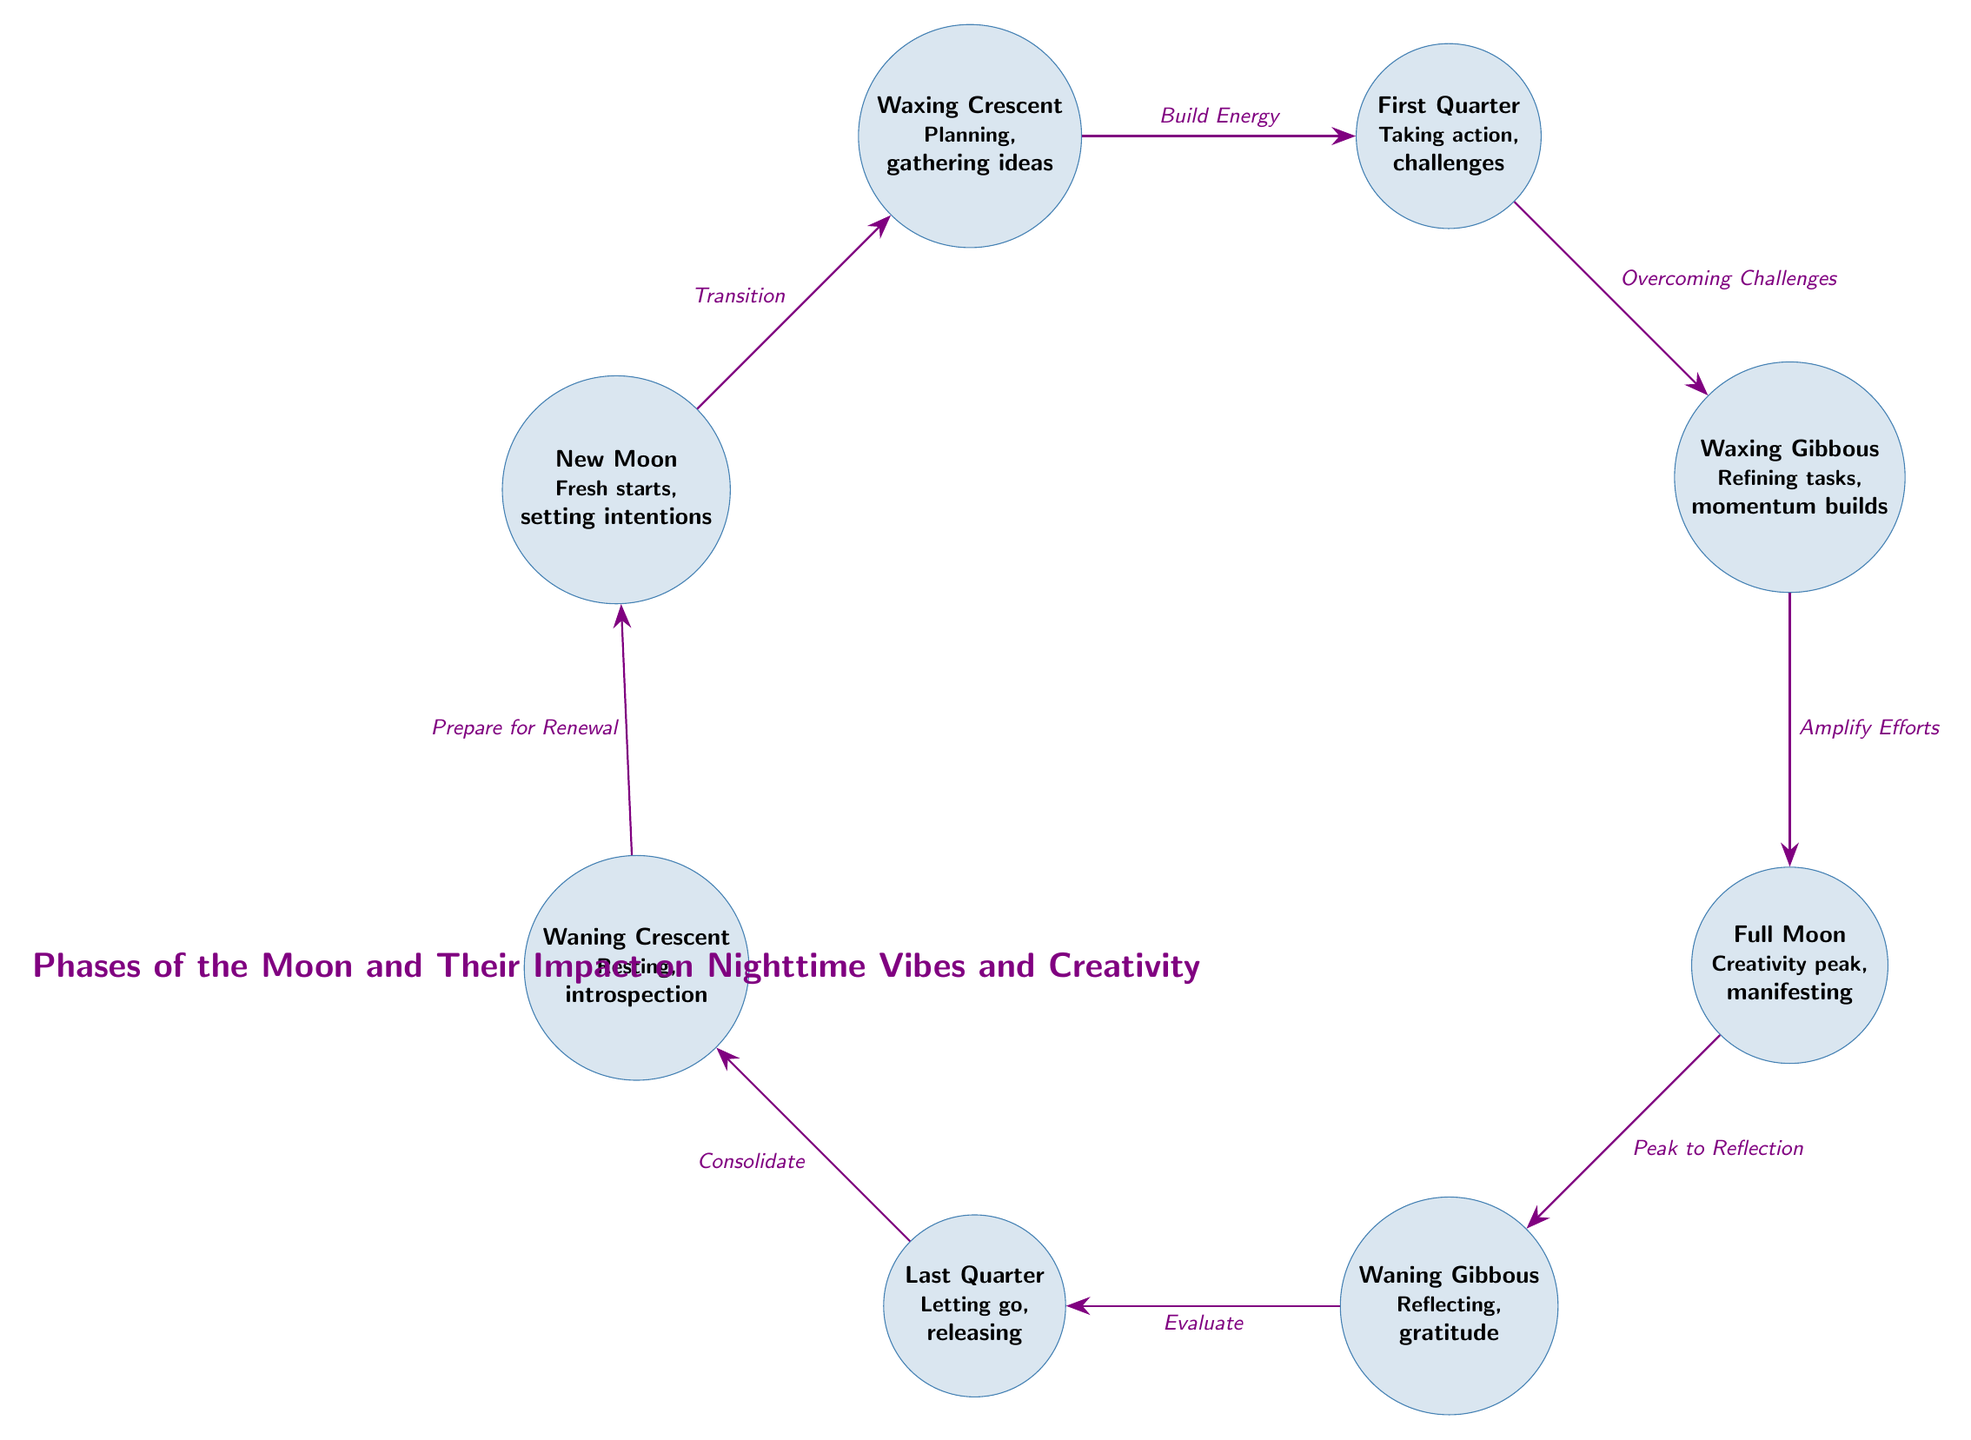What is represented by the node labeled "Full Moon"? The node labeled "Full Moon" represents the concept of "Creativity peak, manifesting." This can be found directly in the diagram, indicating the specific attributes associated with this lunar phase.
Answer: Creativity peak, manifesting How many transition arrows are in the diagram? Counting the arrows that connect the nodes gives a total of 7 transition arrows in the diagram. This can be verified by visually counting all the arrows that connect the phases.
Answer: 7 What emotion does the "Waning Gibbous" phase evoke? The "Waning Gibbous" phase evokes the emotion of reflection and gratitude as indicated in the node label, which describes its associated concepts.
Answer: Reflecting, gratitude What is the first phase in the diagram? The first phase indicated in the diagram is the "New Moon." This is positioned at the top left of the diagram, marking the starting point of the moon’s phases.
Answer: New Moon Describe the relationship between "Waxing Cresent" and "First Quarter." The relationship is described by the transition arrow labeled "Build Energy," connecting the "Waxing Crescent" phase to the "First Quarter" phase, indicating a progression in the lunar cycle.
Answer: Build Energy What does "Last Quarter" entail according to the diagram? The "Last Quarter" entails the concepts of letting go and releasing, as specified in the information presented within the node itself.
Answer: Letting go, releasing Which phase follows "Waxing Gibbous"? The phase that follows "Waxing Gibbous" is the "Full Moon," as shown by the transition arrow connected beneath it in the flow of the diagram.
Answer: Full Moon What is the overall theme of the diagram? The overall theme of the diagram is reflected in the title at the bottom, highlighting the phases of the moon and their impact on nighttime vibes and creativity as a central focus.
Answer: Phases of the Moon and Their Impact on Nighttime Vibes and Creativity 